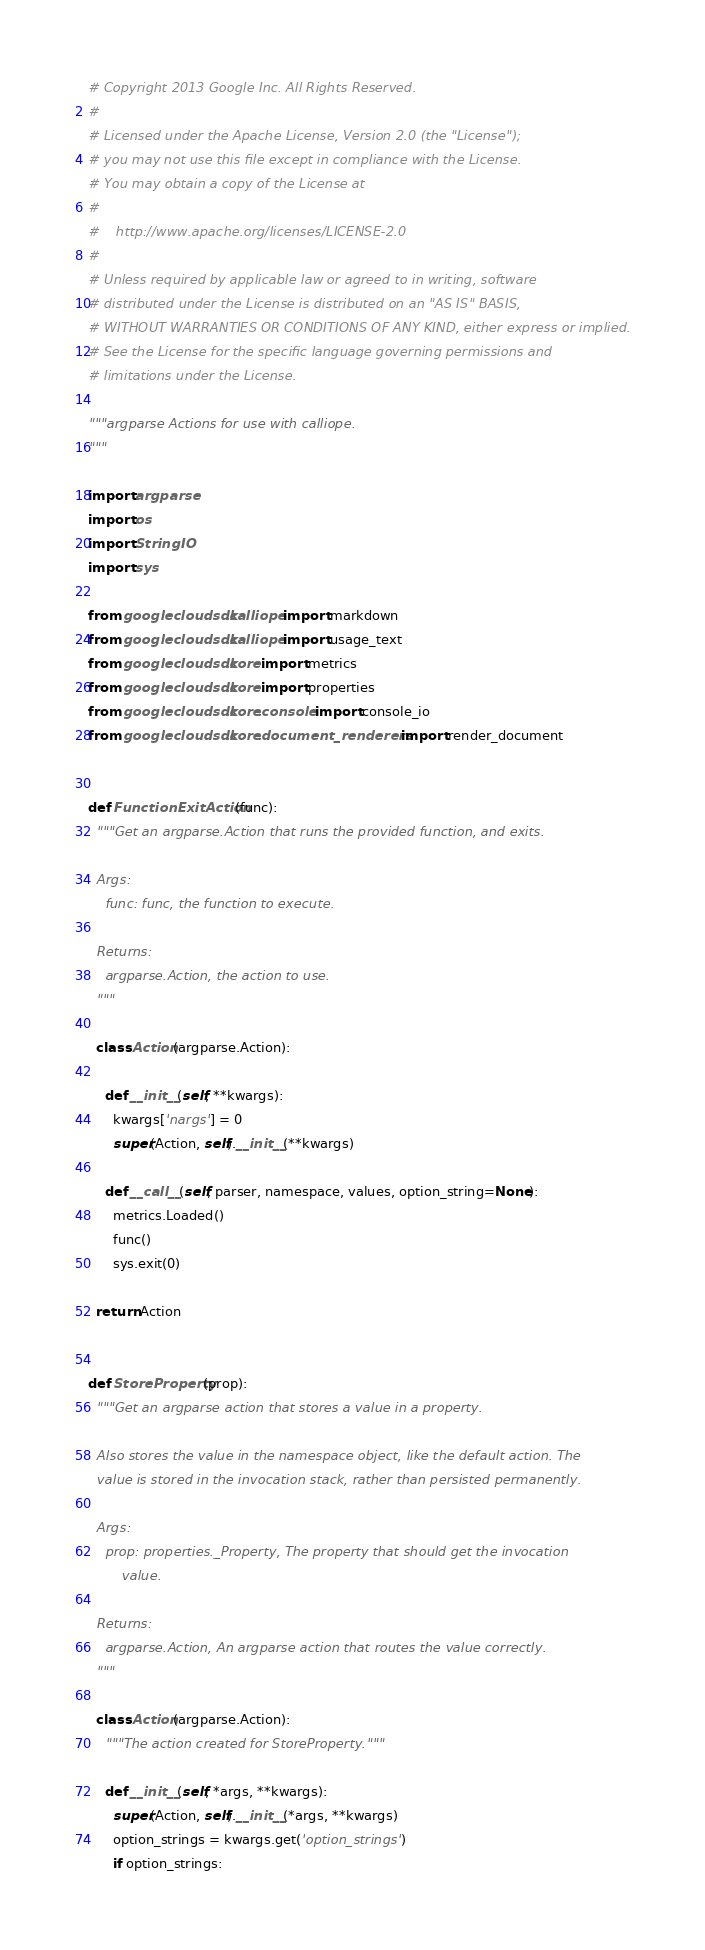<code> <loc_0><loc_0><loc_500><loc_500><_Python_># Copyright 2013 Google Inc. All Rights Reserved.
#
# Licensed under the Apache License, Version 2.0 (the "License");
# you may not use this file except in compliance with the License.
# You may obtain a copy of the License at
#
#    http://www.apache.org/licenses/LICENSE-2.0
#
# Unless required by applicable law or agreed to in writing, software
# distributed under the License is distributed on an "AS IS" BASIS,
# WITHOUT WARRANTIES OR CONDITIONS OF ANY KIND, either express or implied.
# See the License for the specific language governing permissions and
# limitations under the License.

"""argparse Actions for use with calliope.
"""

import argparse
import os
import StringIO
import sys

from googlecloudsdk.calliope import markdown
from googlecloudsdk.calliope import usage_text
from googlecloudsdk.core import metrics
from googlecloudsdk.core import properties
from googlecloudsdk.core.console import console_io
from googlecloudsdk.core.document_renderers import render_document


def FunctionExitAction(func):
  """Get an argparse.Action that runs the provided function, and exits.

  Args:
    func: func, the function to execute.

  Returns:
    argparse.Action, the action to use.
  """

  class Action(argparse.Action):

    def __init__(self, **kwargs):
      kwargs['nargs'] = 0
      super(Action, self).__init__(**kwargs)

    def __call__(self, parser, namespace, values, option_string=None):
      metrics.Loaded()
      func()
      sys.exit(0)

  return Action


def StoreProperty(prop):
  """Get an argparse action that stores a value in a property.

  Also stores the value in the namespace object, like the default action. The
  value is stored in the invocation stack, rather than persisted permanently.

  Args:
    prop: properties._Property, The property that should get the invocation
        value.

  Returns:
    argparse.Action, An argparse action that routes the value correctly.
  """

  class Action(argparse.Action):
    """The action created for StoreProperty."""

    def __init__(self, *args, **kwargs):
      super(Action, self).__init__(*args, **kwargs)
      option_strings = kwargs.get('option_strings')
      if option_strings:</code> 